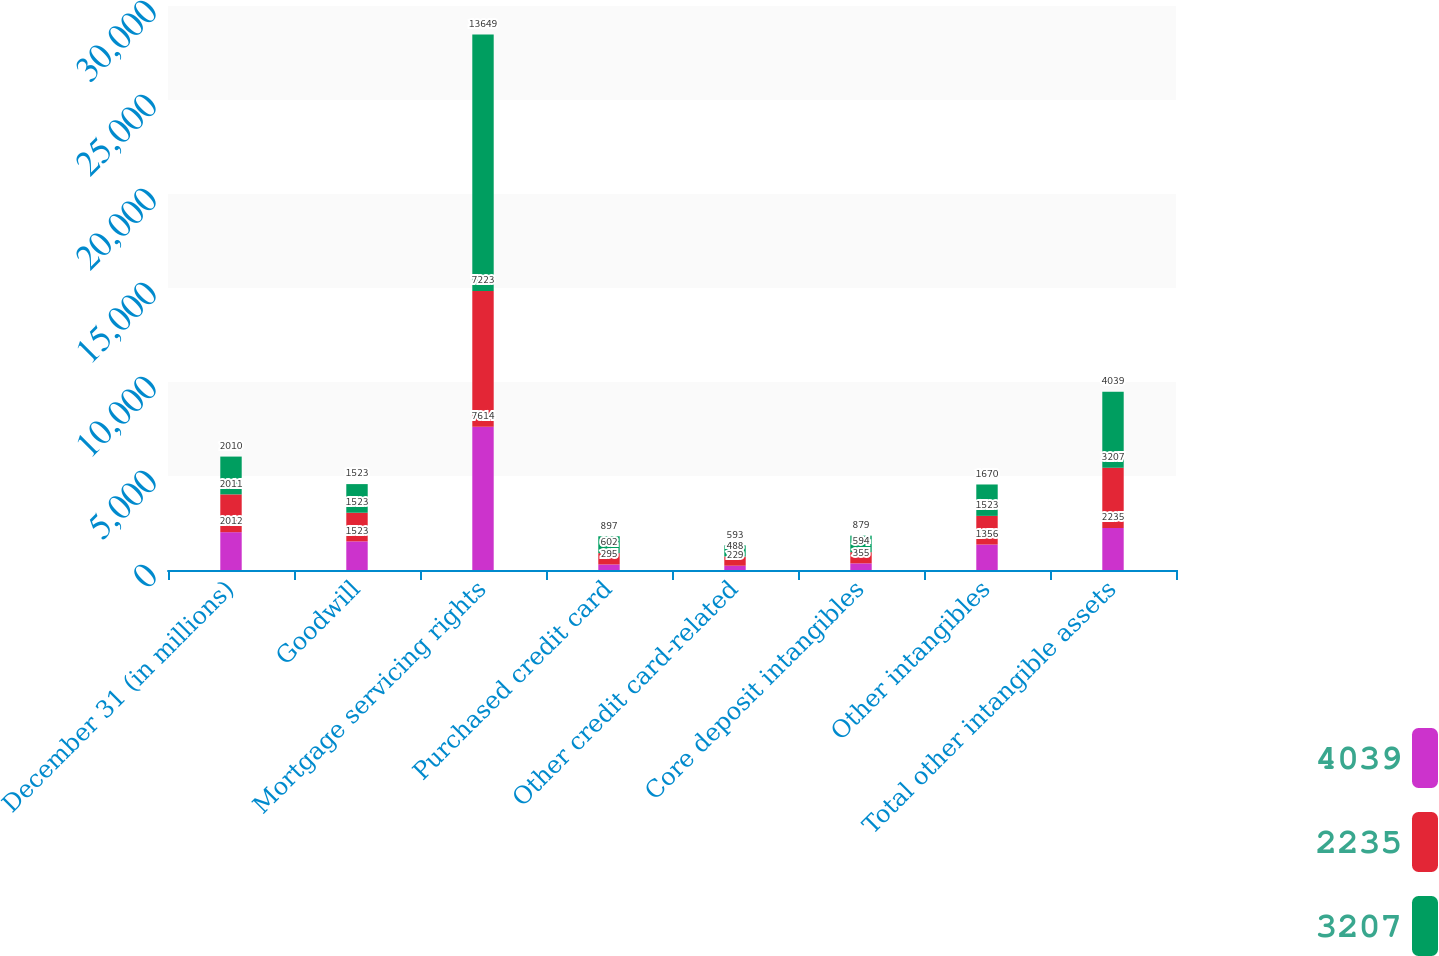<chart> <loc_0><loc_0><loc_500><loc_500><stacked_bar_chart><ecel><fcel>December 31 (in millions)<fcel>Goodwill<fcel>Mortgage servicing rights<fcel>Purchased credit card<fcel>Other credit card-related<fcel>Core deposit intangibles<fcel>Other intangibles<fcel>Total other intangible assets<nl><fcel>4039<fcel>2012<fcel>1523<fcel>7614<fcel>295<fcel>229<fcel>355<fcel>1356<fcel>2235<nl><fcel>2235<fcel>2011<fcel>1523<fcel>7223<fcel>602<fcel>488<fcel>594<fcel>1523<fcel>3207<nl><fcel>3207<fcel>2010<fcel>1523<fcel>13649<fcel>897<fcel>593<fcel>879<fcel>1670<fcel>4039<nl></chart> 